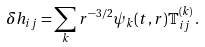Convert formula to latex. <formula><loc_0><loc_0><loc_500><loc_500>\delta h _ { i j } = \sum _ { k } { r ^ { - 3 / 2 } } { \psi _ { k } ( t , r ) } \mathbb { T } ^ { ( k ) } _ { i j } \, .</formula> 